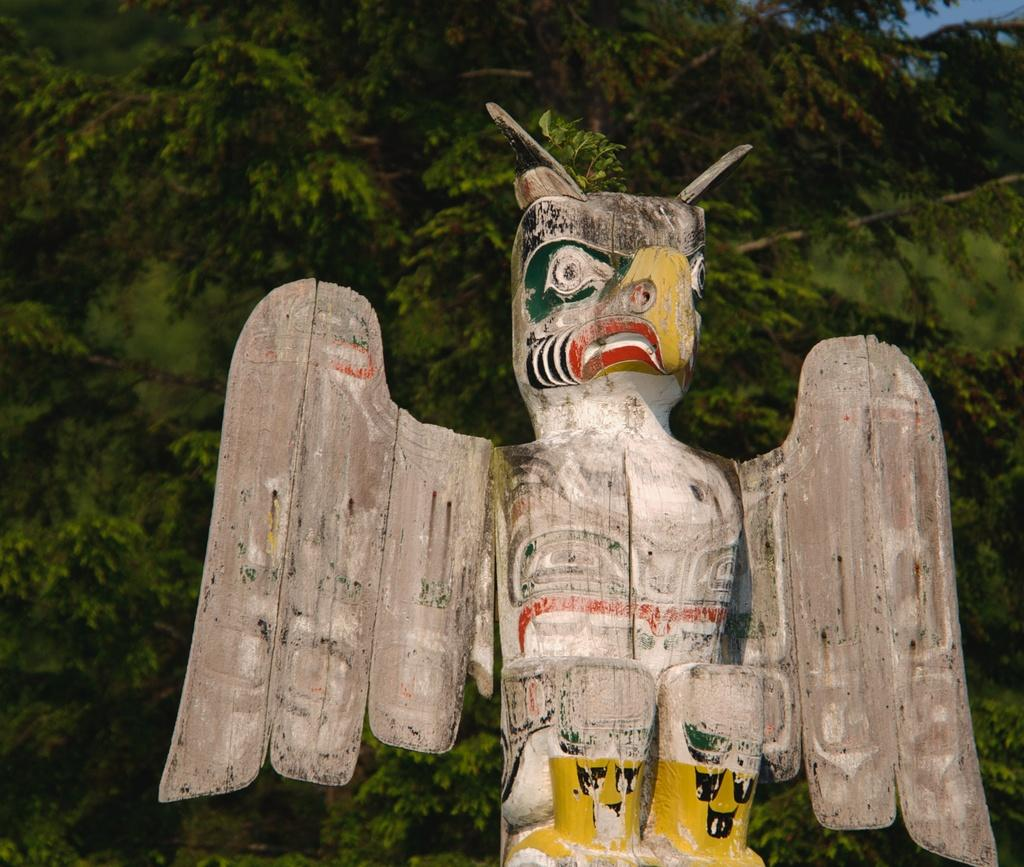What is the main subject of the image? There is a sculpture of a bird in the center of the image. What can be seen in the background of the image? There are trees in the background of the image. What type of cork can be seen on the ground in the image? There is no cork present in the image. How many people are visible in the image? There are no people visible in the image. 